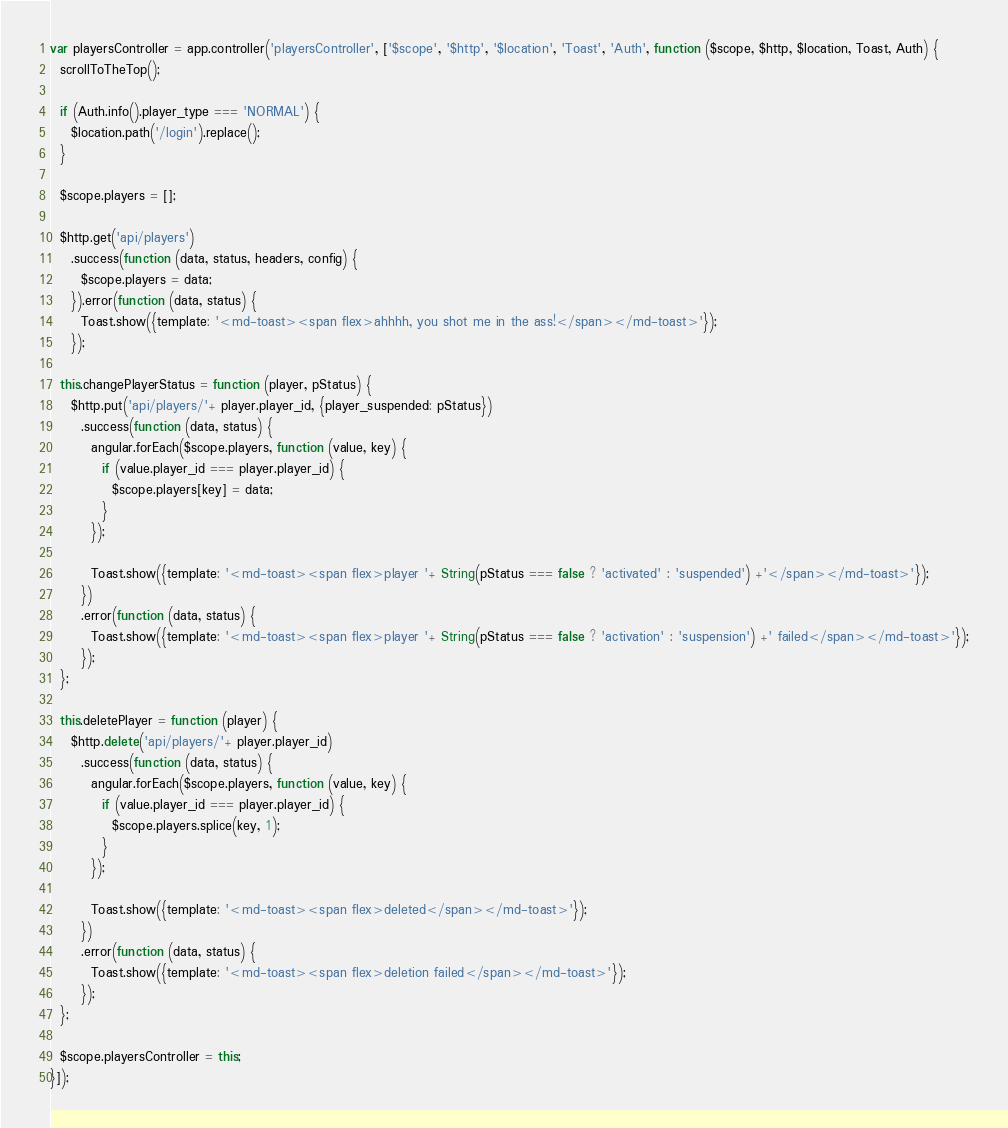Convert code to text. <code><loc_0><loc_0><loc_500><loc_500><_JavaScript_>var playersController = app.controller('playersController', ['$scope', '$http', '$location', 'Toast', 'Auth', function ($scope, $http, $location, Toast, Auth) {
  scrollToTheTop();

  if (Auth.info().player_type === 'NORMAL') {
    $location.path('/login').replace();
  }

  $scope.players = [];

  $http.get('api/players')
    .success(function (data, status, headers, config) {
      $scope.players = data;
    }).error(function (data, status) {
      Toast.show({template: '<md-toast><span flex>ahhhh, you shot me in the ass!</span></md-toast>'});
    });

  this.changePlayerStatus = function (player, pStatus) {
    $http.put('api/players/'+ player.player_id, {player_suspended: pStatus})
      .success(function (data, status) {
        angular.forEach($scope.players, function (value, key) {
          if (value.player_id === player.player_id) {
            $scope.players[key] = data;
          }
        });

        Toast.show({template: '<md-toast><span flex>player '+ String(pStatus === false ? 'activated' : 'suspended') +'</span></md-toast>'});
      })
      .error(function (data, status) {
        Toast.show({template: '<md-toast><span flex>player '+ String(pStatus === false ? 'activation' : 'suspension') +' failed</span></md-toast>'});
      });
  };

  this.deletePlayer = function (player) {
    $http.delete('api/players/'+ player.player_id)
      .success(function (data, status) {
        angular.forEach($scope.players, function (value, key) {
          if (value.player_id === player.player_id) {
            $scope.players.splice(key, 1);
          }
        });

        Toast.show({template: '<md-toast><span flex>deleted</span></md-toast>'});
      })
      .error(function (data, status) {
        Toast.show({template: '<md-toast><span flex>deletion failed</span></md-toast>'});
      });
  };

  $scope.playersController = this;
}]);
</code> 